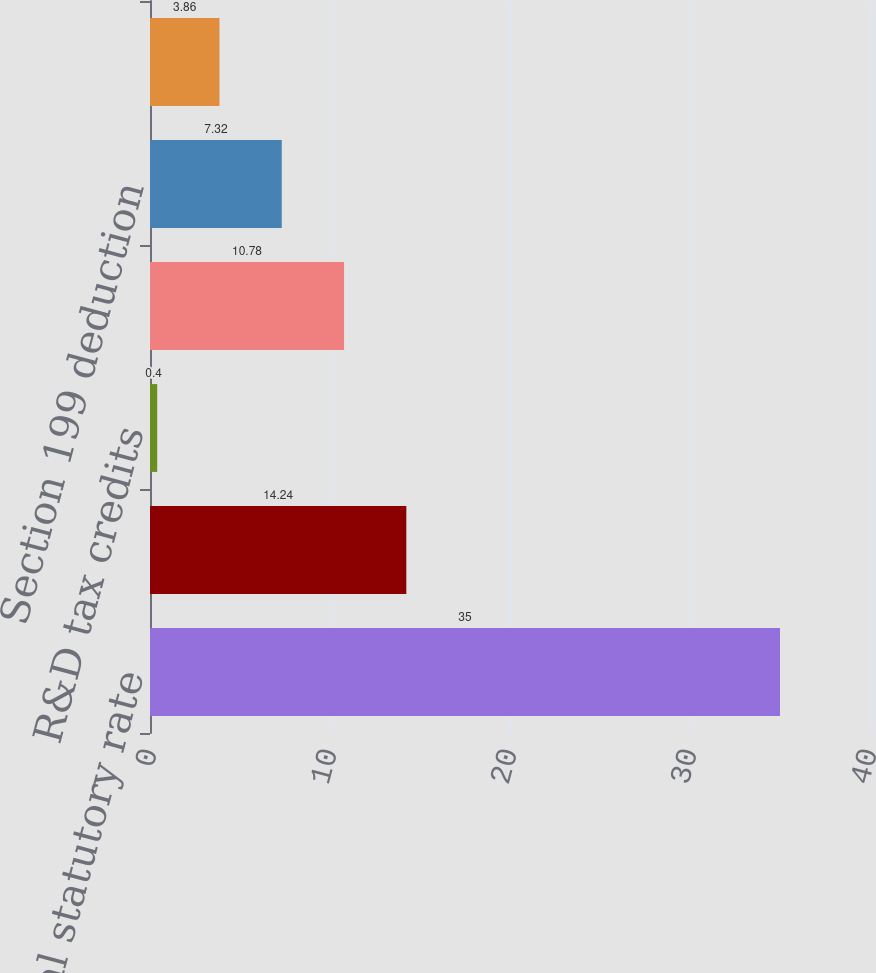Convert chart. <chart><loc_0><loc_0><loc_500><loc_500><bar_chart><fcel>Federal statutory rate<fcel>Foreign rate differential<fcel>R&D tax credits<fcel>State taxes net of federal<fcel>Section 199 deduction<fcel>Other net<nl><fcel>35<fcel>14.24<fcel>0.4<fcel>10.78<fcel>7.32<fcel>3.86<nl></chart> 